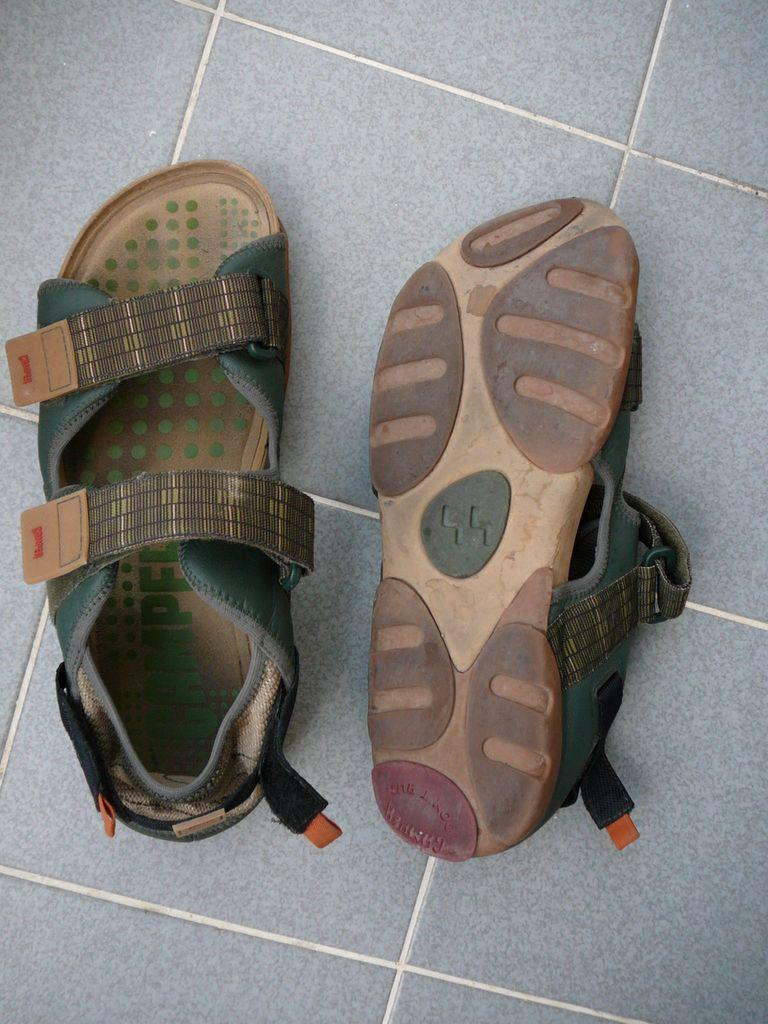How many sandals are visible in the image? There are two sandals in the image. Where is the first sandal located? One sandal is on the left side of the image. What is the position of the sandal on the left side? The sandal on the left side is in an upward direction. Where is the second sandal located? The other sandal is on the right side of the image. What is the position of the sandal on the right side? The sandal on the right side is in a reverse direction. What type of rabbit can be seen designing a brain in the image? There is no rabbit or brain present in the image; it only features two sandals in different positions. 